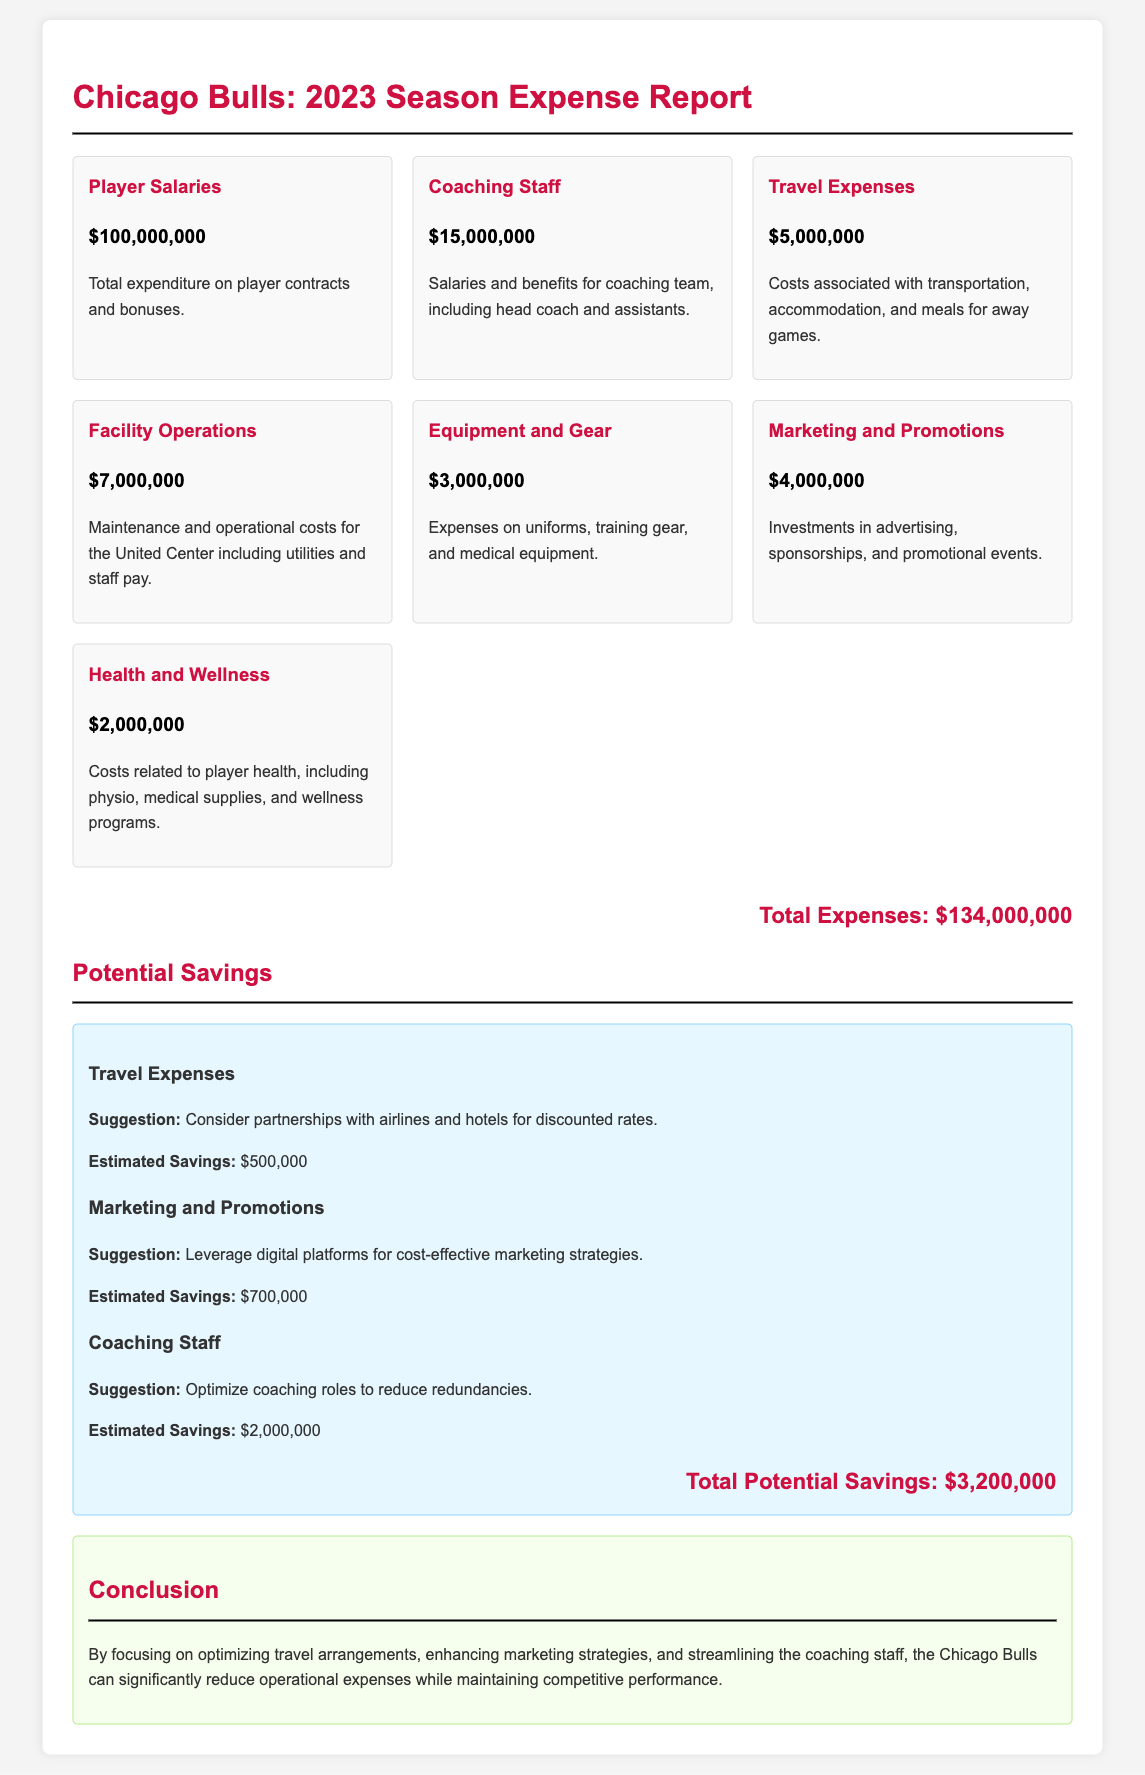What is the total expenditure on player contracts and bonuses? This information is found under the "Player Salaries" category in the document, which lists the amount as $100,000,000.
Answer: $100,000,000 What is the amount allocated for coaching staff salaries and benefits? Under the "Coaching Staff" category, the document specifies the total amount as $15,000,000.
Answer: $15,000,000 What are the estimated savings from travel expenses? The document lists "Travel Expenses" with an estimated savings of $500,000 under the potential savings section.
Answer: $500,000 What is the total amount spent on marketing and promotions? The "Marketing and Promotions" section states the expenditure is $4,000,000.
Answer: $4,000,000 What is the total potential savings identified in the report? The total potential savings figure is mentioned at the end of the savings section, which sums up to $3,200,000.
Answer: $3,200,000 Which category of expenses suggests leveraging digital platforms for cost-effective marketing? This suggestion is noted under "Marketing and Promotions" where cost-effective strategies are mentioned.
Answer: Marketing and Promotions What are the maintenance costs associated with the United Center listed as? This is categorized under "Facility Operations," which mentions the amount as $7,000,000.
Answer: $7,000,000 What category covers costs related to player health and wellness? The document refers to this expense under "Health and Wellness,” which totals $2,000,000.
Answer: Health and Wellness What is the conclusion related to potential areas for cost reduction? The conclusion emphasizes optimizing travel arrangements, enhancing marketing strategies, and streamlining the coaching staff for savings.
Answer: Optimize travel arrangements, enhance marketing strategies, streamline coaching staff 